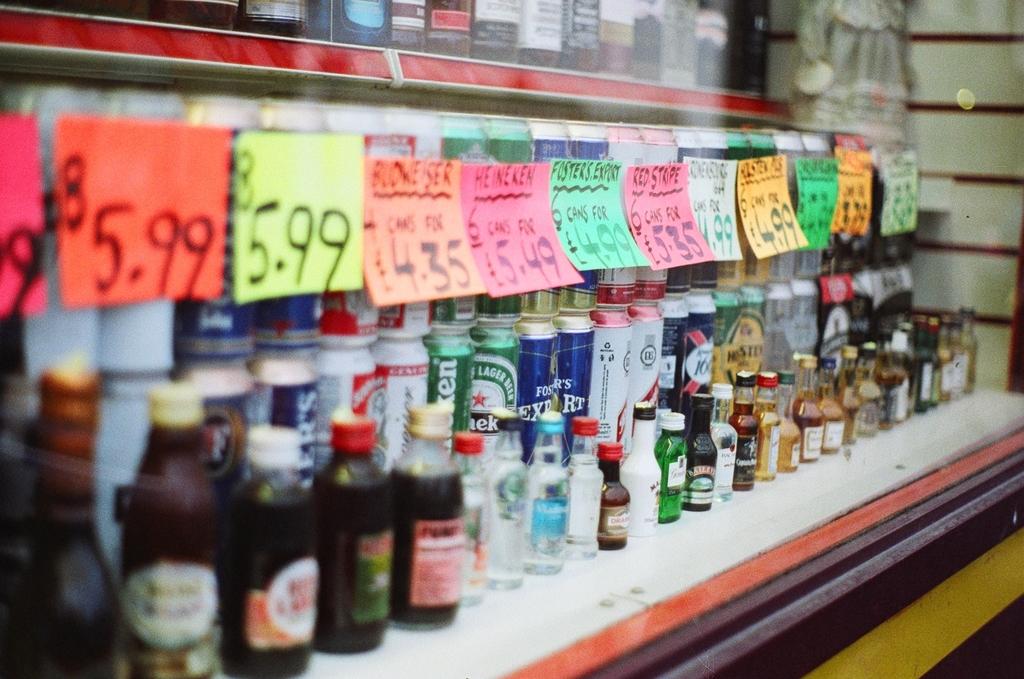How much is shown on the orange sign on the left?
Provide a succinct answer. 5.99. What is the price on the yellow sign?
Your answer should be very brief. 5.99. 